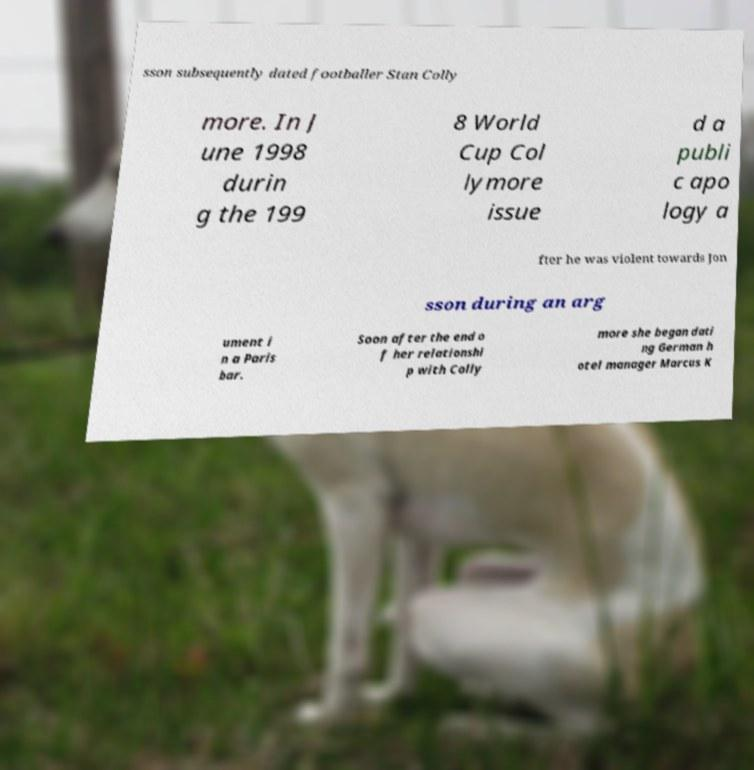There's text embedded in this image that I need extracted. Can you transcribe it verbatim? sson subsequently dated footballer Stan Colly more. In J une 1998 durin g the 199 8 World Cup Col lymore issue d a publi c apo logy a fter he was violent towards Jon sson during an arg ument i n a Paris bar. Soon after the end o f her relationshi p with Colly more she began dati ng German h otel manager Marcus K 